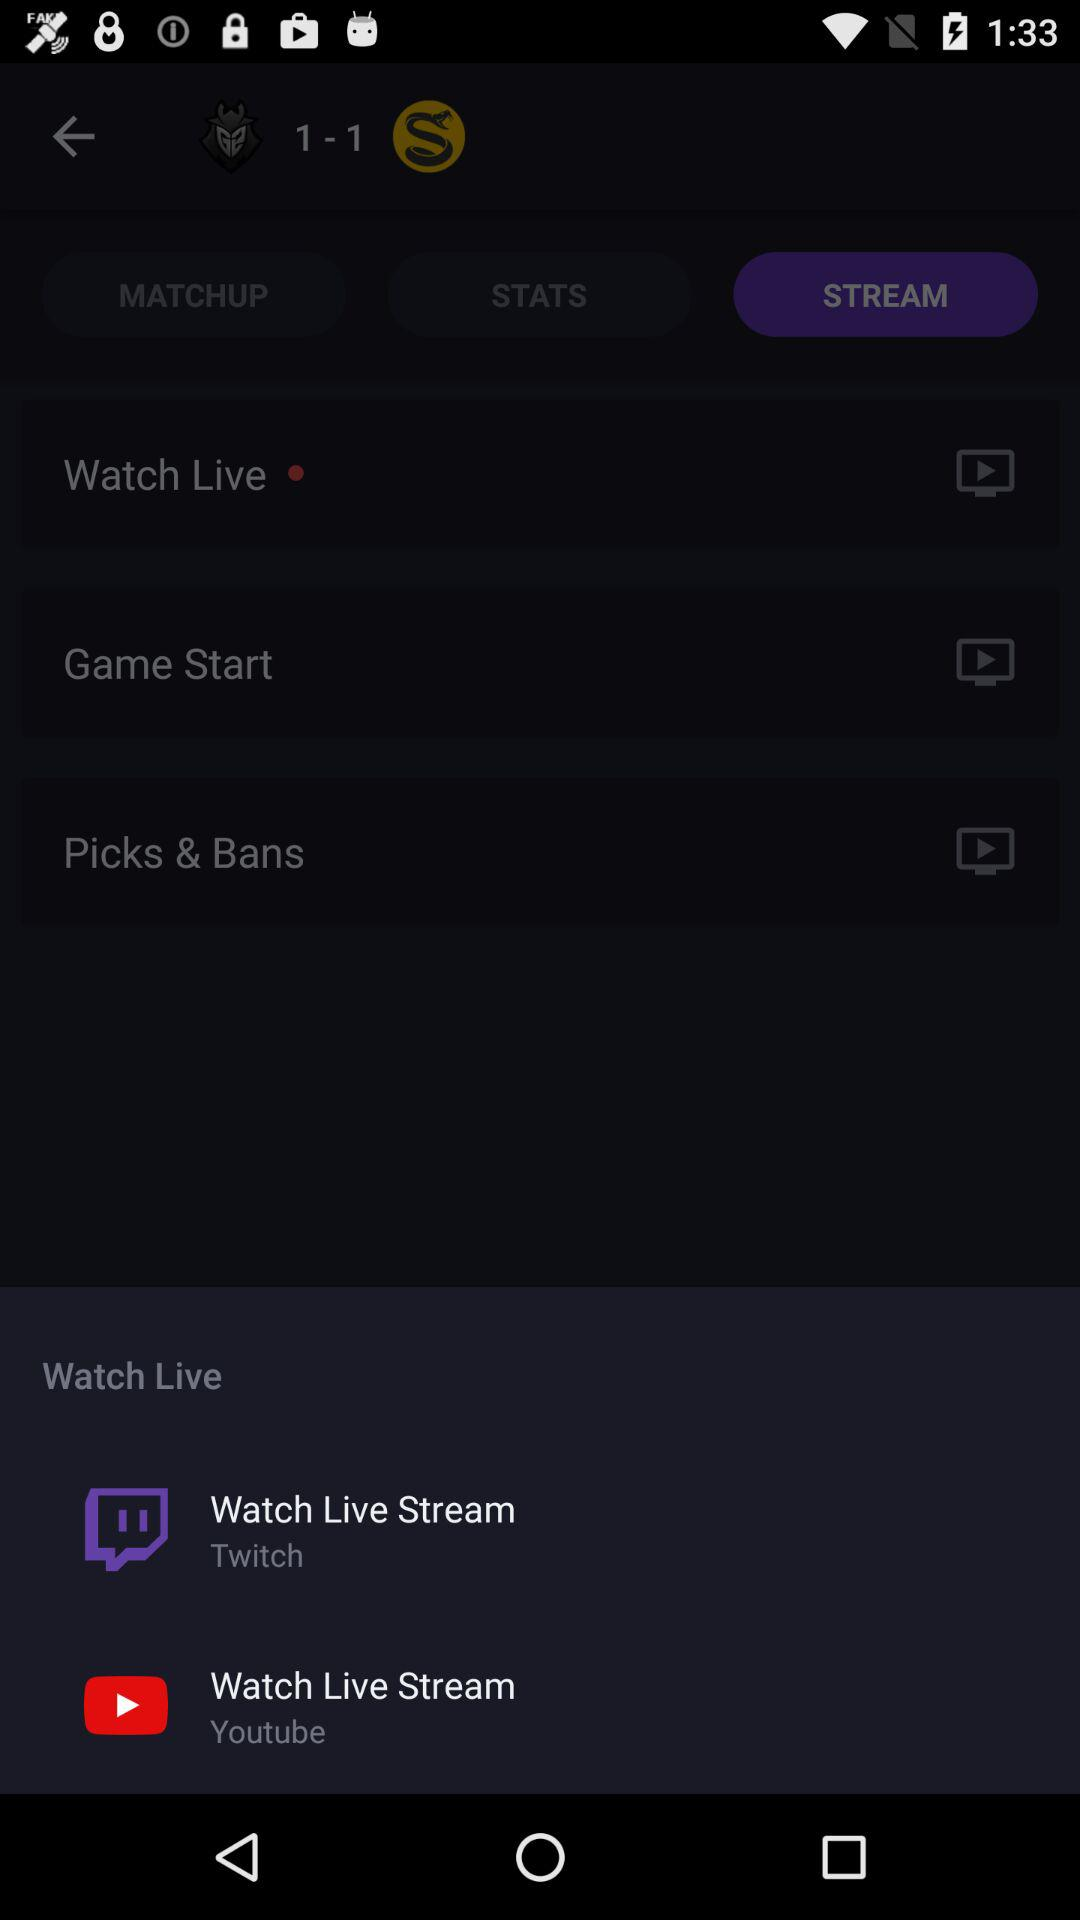Which videos are streaming live?
When the provided information is insufficient, respond with <no answer>. <no answer> 